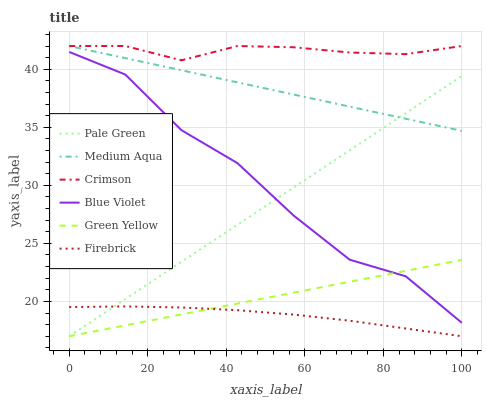Does Firebrick have the minimum area under the curve?
Answer yes or no. Yes. Does Crimson have the maximum area under the curve?
Answer yes or no. Yes. Does Pale Green have the minimum area under the curve?
Answer yes or no. No. Does Pale Green have the maximum area under the curve?
Answer yes or no. No. Is Green Yellow the smoothest?
Answer yes or no. Yes. Is Blue Violet the roughest?
Answer yes or no. Yes. Is Pale Green the smoothest?
Answer yes or no. No. Is Pale Green the roughest?
Answer yes or no. No. Does Firebrick have the lowest value?
Answer yes or no. Yes. Does Medium Aqua have the lowest value?
Answer yes or no. No. Does Crimson have the highest value?
Answer yes or no. Yes. Does Pale Green have the highest value?
Answer yes or no. No. Is Blue Violet less than Medium Aqua?
Answer yes or no. Yes. Is Crimson greater than Firebrick?
Answer yes or no. Yes. Does Crimson intersect Medium Aqua?
Answer yes or no. Yes. Is Crimson less than Medium Aqua?
Answer yes or no. No. Is Crimson greater than Medium Aqua?
Answer yes or no. No. Does Blue Violet intersect Medium Aqua?
Answer yes or no. No. 